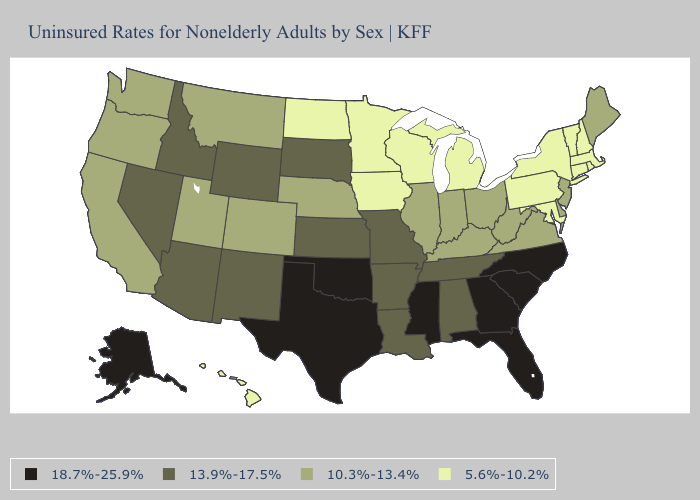What is the highest value in states that border Illinois?
Give a very brief answer. 13.9%-17.5%. What is the lowest value in the South?
Short answer required. 5.6%-10.2%. Name the states that have a value in the range 5.6%-10.2%?
Short answer required. Connecticut, Hawaii, Iowa, Maryland, Massachusetts, Michigan, Minnesota, New Hampshire, New York, North Dakota, Pennsylvania, Rhode Island, Vermont, Wisconsin. Among the states that border New Mexico , does Oklahoma have the highest value?
Be succinct. Yes. Name the states that have a value in the range 10.3%-13.4%?
Write a very short answer. California, Colorado, Delaware, Illinois, Indiana, Kentucky, Maine, Montana, Nebraska, New Jersey, Ohio, Oregon, Utah, Virginia, Washington, West Virginia. What is the value of New York?
Be succinct. 5.6%-10.2%. Name the states that have a value in the range 13.9%-17.5%?
Write a very short answer. Alabama, Arizona, Arkansas, Idaho, Kansas, Louisiana, Missouri, Nevada, New Mexico, South Dakota, Tennessee, Wyoming. Which states have the highest value in the USA?
Write a very short answer. Alaska, Florida, Georgia, Mississippi, North Carolina, Oklahoma, South Carolina, Texas. Which states hav the highest value in the MidWest?
Give a very brief answer. Kansas, Missouri, South Dakota. What is the lowest value in the USA?
Be succinct. 5.6%-10.2%. Which states have the lowest value in the MidWest?
Quick response, please. Iowa, Michigan, Minnesota, North Dakota, Wisconsin. Does the first symbol in the legend represent the smallest category?
Concise answer only. No. What is the lowest value in the USA?
Answer briefly. 5.6%-10.2%. What is the value of Colorado?
Short answer required. 10.3%-13.4%. Name the states that have a value in the range 10.3%-13.4%?
Answer briefly. California, Colorado, Delaware, Illinois, Indiana, Kentucky, Maine, Montana, Nebraska, New Jersey, Ohio, Oregon, Utah, Virginia, Washington, West Virginia. 